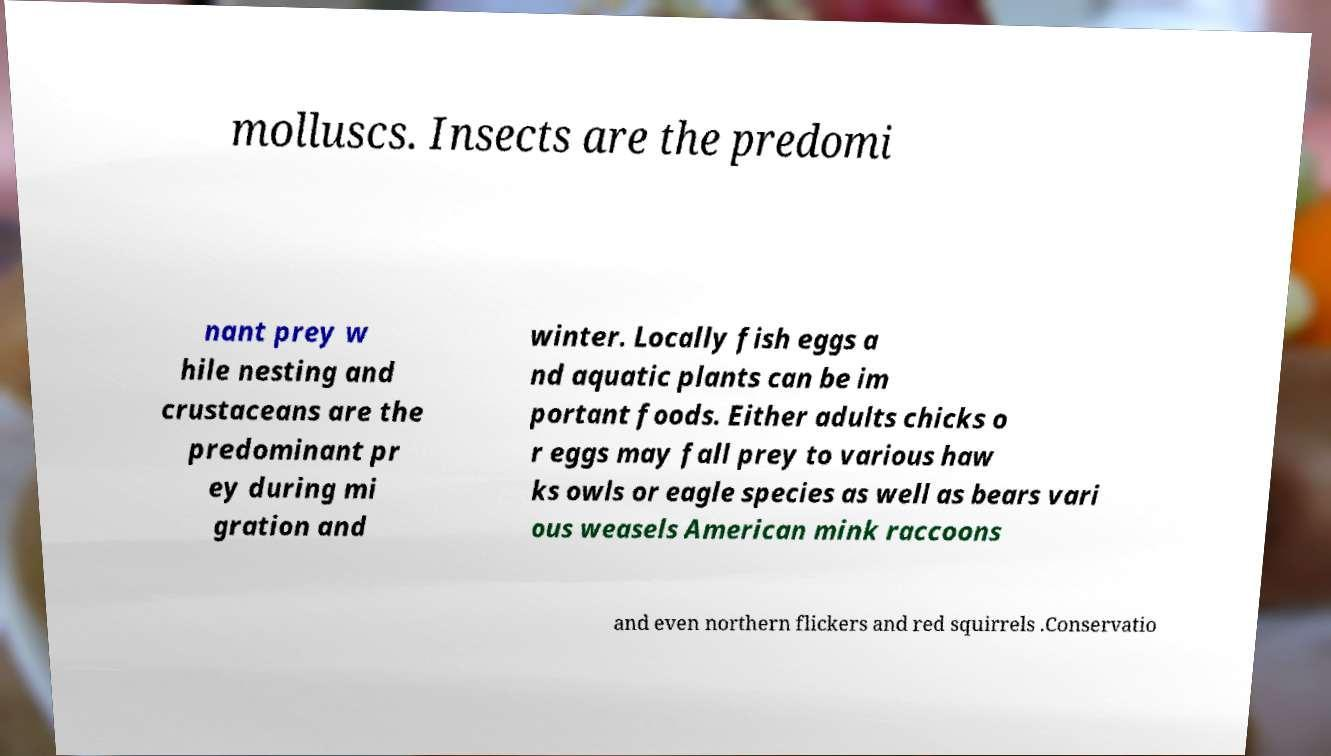Could you assist in decoding the text presented in this image and type it out clearly? molluscs. Insects are the predomi nant prey w hile nesting and crustaceans are the predominant pr ey during mi gration and winter. Locally fish eggs a nd aquatic plants can be im portant foods. Either adults chicks o r eggs may fall prey to various haw ks owls or eagle species as well as bears vari ous weasels American mink raccoons and even northern flickers and red squirrels .Conservatio 